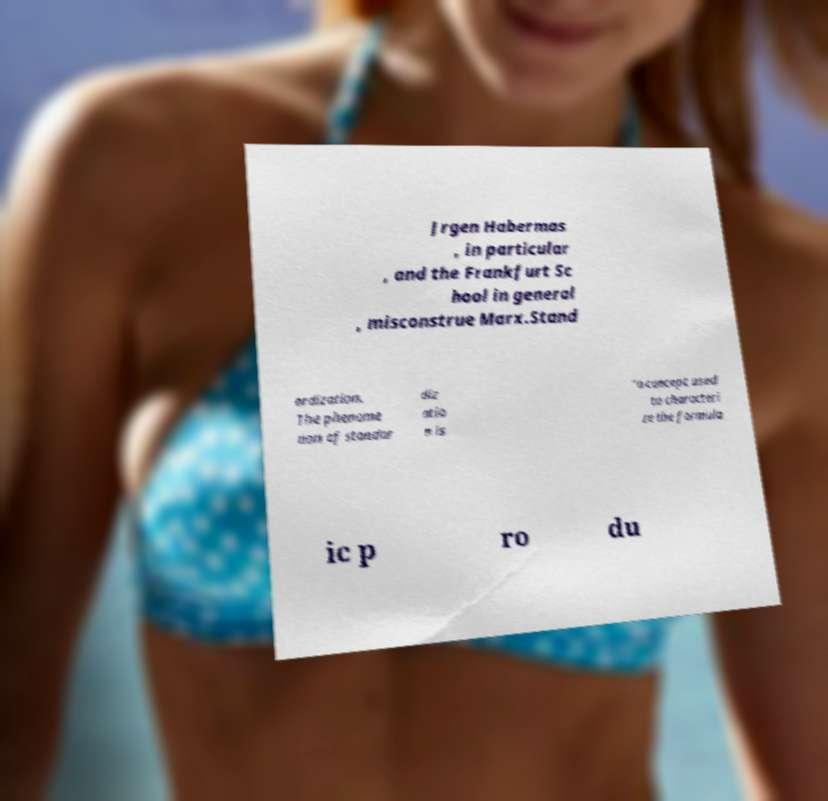Could you extract and type out the text from this image? Jrgen Habermas , in particular , and the Frankfurt Sc hool in general , misconstrue Marx.Stand ardization. The phenome non of standar diz atio n is "a concept used to characteri ze the formula ic p ro du 